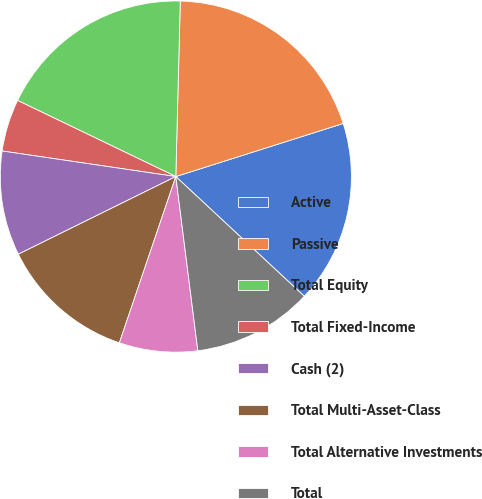<chart> <loc_0><loc_0><loc_500><loc_500><pie_chart><fcel>Active<fcel>Passive<fcel>Total Equity<fcel>Total Fixed-Income<fcel>Cash (2)<fcel>Total Multi-Asset-Class<fcel>Total Alternative Investments<fcel>Total<nl><fcel>16.83%<fcel>19.71%<fcel>18.27%<fcel>4.81%<fcel>9.62%<fcel>12.5%<fcel>7.21%<fcel>11.06%<nl></chart> 